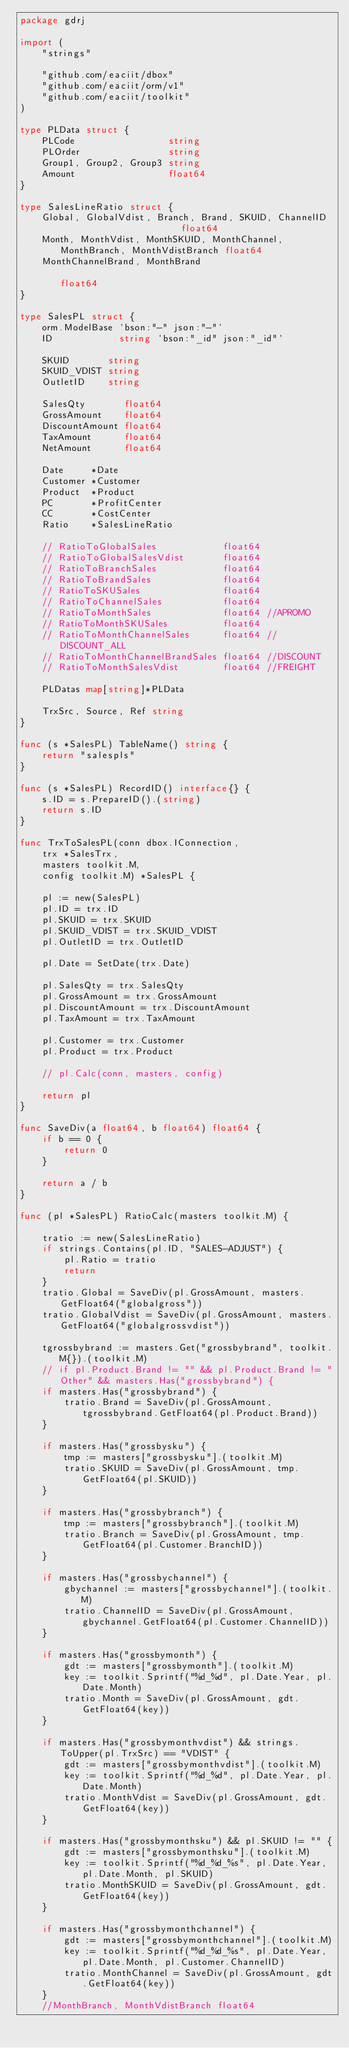Convert code to text. <code><loc_0><loc_0><loc_500><loc_500><_Go_>package gdrj

import (
	"strings"

	"github.com/eaciit/dbox"
	"github.com/eaciit/orm/v1"
	"github.com/eaciit/toolkit"
)

type PLData struct {
	PLCode                 string
	PLOrder                string
	Group1, Group2, Group3 string
	Amount                 float64
}

type SalesLineRatio struct {
	Global, GlobalVdist, Branch, Brand, SKUID, ChannelID                       float64
	Month, MonthVdist, MonthSKUID, MonthChannel, MonthBranch, MonthVdistBranch float64
	MonthChannelBrand, MonthBrand                                              float64
}

type SalesPL struct {
	orm.ModelBase `bson:"-" json:"-"`
	ID            string `bson:"_id" json:"_id"`

	SKUID       string
	SKUID_VDIST string
	OutletID    string

	SalesQty       float64
	GrossAmount    float64
	DiscountAmount float64
	TaxAmount      float64
	NetAmount      float64

	Date     *Date
	Customer *Customer
	Product  *Product
	PC       *ProfitCenter
	CC       *CostCenter
	Ratio    *SalesLineRatio

	// RatioToGlobalSales            float64
	// RatioToGlobalSalesVdist       float64
	// RatioToBranchSales            float64
	// RatioToBrandSales             float64
	// RatioToSKUSales               float64
	// RatioToChannelSales           float64
	// RatioToMonthSales             float64 //APROMO
	// RatioToMonthSKUSales          float64
	// RatioToMonthChannelSales      float64 //DISCOUNT_ALL
	// RatioToMonthChannelBrandSales float64 //DISCOUNT
	// RatioToMonthSalesVdist        float64 //FREIGHT

	PLDatas map[string]*PLData

	TrxSrc, Source, Ref string
}

func (s *SalesPL) TableName() string {
	return "salespls"
}

func (s *SalesPL) RecordID() interface{} {
	s.ID = s.PrepareID().(string)
	return s.ID
}

func TrxToSalesPL(conn dbox.IConnection,
	trx *SalesTrx,
	masters toolkit.M,
	config toolkit.M) *SalesPL {

	pl := new(SalesPL)
	pl.ID = trx.ID
	pl.SKUID = trx.SKUID
	pl.SKUID_VDIST = trx.SKUID_VDIST
	pl.OutletID = trx.OutletID

	pl.Date = SetDate(trx.Date)

	pl.SalesQty = trx.SalesQty
	pl.GrossAmount = trx.GrossAmount
	pl.DiscountAmount = trx.DiscountAmount
	pl.TaxAmount = trx.TaxAmount

	pl.Customer = trx.Customer
	pl.Product = trx.Product

	// pl.Calc(conn, masters, config)

	return pl
}

func SaveDiv(a float64, b float64) float64 {
	if b == 0 {
		return 0
	}

	return a / b
}

func (pl *SalesPL) RatioCalc(masters toolkit.M) {

	tratio := new(SalesLineRatio)
	if strings.Contains(pl.ID, "SALES-ADJUST") {
		pl.Ratio = tratio
		return
	}
	tratio.Global = SaveDiv(pl.GrossAmount, masters.GetFloat64("globalgross"))
	tratio.GlobalVdist = SaveDiv(pl.GrossAmount, masters.GetFloat64("globalgrossvdist"))

	tgrossbybrand := masters.Get("grossbybrand", toolkit.M{}).(toolkit.M)
	// if pl.Product.Brand != "" && pl.Product.Brand != "Other" && masters.Has("grossbybrand") {
	if masters.Has("grossbybrand") {
		tratio.Brand = SaveDiv(pl.GrossAmount, tgrossbybrand.GetFloat64(pl.Product.Brand))
	}

	if masters.Has("grossbysku") {
		tmp := masters["grossbysku"].(toolkit.M)
		tratio.SKUID = SaveDiv(pl.GrossAmount, tmp.GetFloat64(pl.SKUID))
	}

	if masters.Has("grossbybranch") {
		tmp := masters["grossbybranch"].(toolkit.M)
		tratio.Branch = SaveDiv(pl.GrossAmount, tmp.GetFloat64(pl.Customer.BranchID))
	}

	if masters.Has("grossbychannel") {
		gbychannel := masters["grossbychannel"].(toolkit.M)
		tratio.ChannelID = SaveDiv(pl.GrossAmount, gbychannel.GetFloat64(pl.Customer.ChannelID))
	}

	if masters.Has("grossbymonth") {
		gdt := masters["grossbymonth"].(toolkit.M)
		key := toolkit.Sprintf("%d_%d", pl.Date.Year, pl.Date.Month)
		tratio.Month = SaveDiv(pl.GrossAmount, gdt.GetFloat64(key))
	}

	if masters.Has("grossbymonthvdist") && strings.ToUpper(pl.TrxSrc) == "VDIST" {
		gdt := masters["grossbymonthvdist"].(toolkit.M)
		key := toolkit.Sprintf("%d_%d", pl.Date.Year, pl.Date.Month)
		tratio.MonthVdist = SaveDiv(pl.GrossAmount, gdt.GetFloat64(key))
	}

	if masters.Has("grossbymonthsku") && pl.SKUID != "" {
		gdt := masters["grossbymonthsku"].(toolkit.M)
		key := toolkit.Sprintf("%d_%d_%s", pl.Date.Year, pl.Date.Month, pl.SKUID)
		tratio.MonthSKUID = SaveDiv(pl.GrossAmount, gdt.GetFloat64(key))
	}

	if masters.Has("grossbymonthchannel") {
		gdt := masters["grossbymonthchannel"].(toolkit.M)
		key := toolkit.Sprintf("%d_%d_%s", pl.Date.Year, pl.Date.Month, pl.Customer.ChannelID)
		tratio.MonthChannel = SaveDiv(pl.GrossAmount, gdt.GetFloat64(key))
	}
	//MonthBranch, MonthVdistBranch float64</code> 